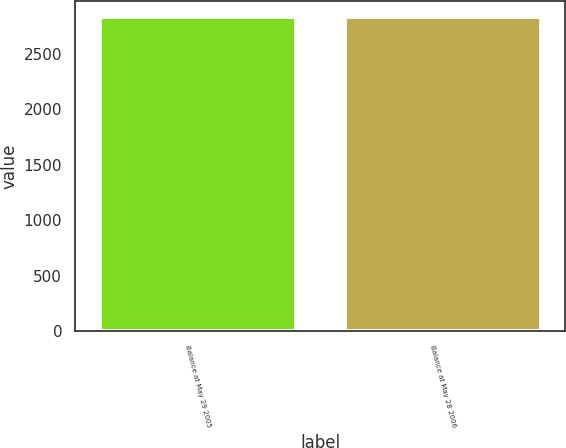<chart> <loc_0><loc_0><loc_500><loc_500><bar_chart><fcel>Balance at May 29 2005<fcel>Balance at May 28 2006<nl><fcel>2829.7<fcel>2831.1<nl></chart> 